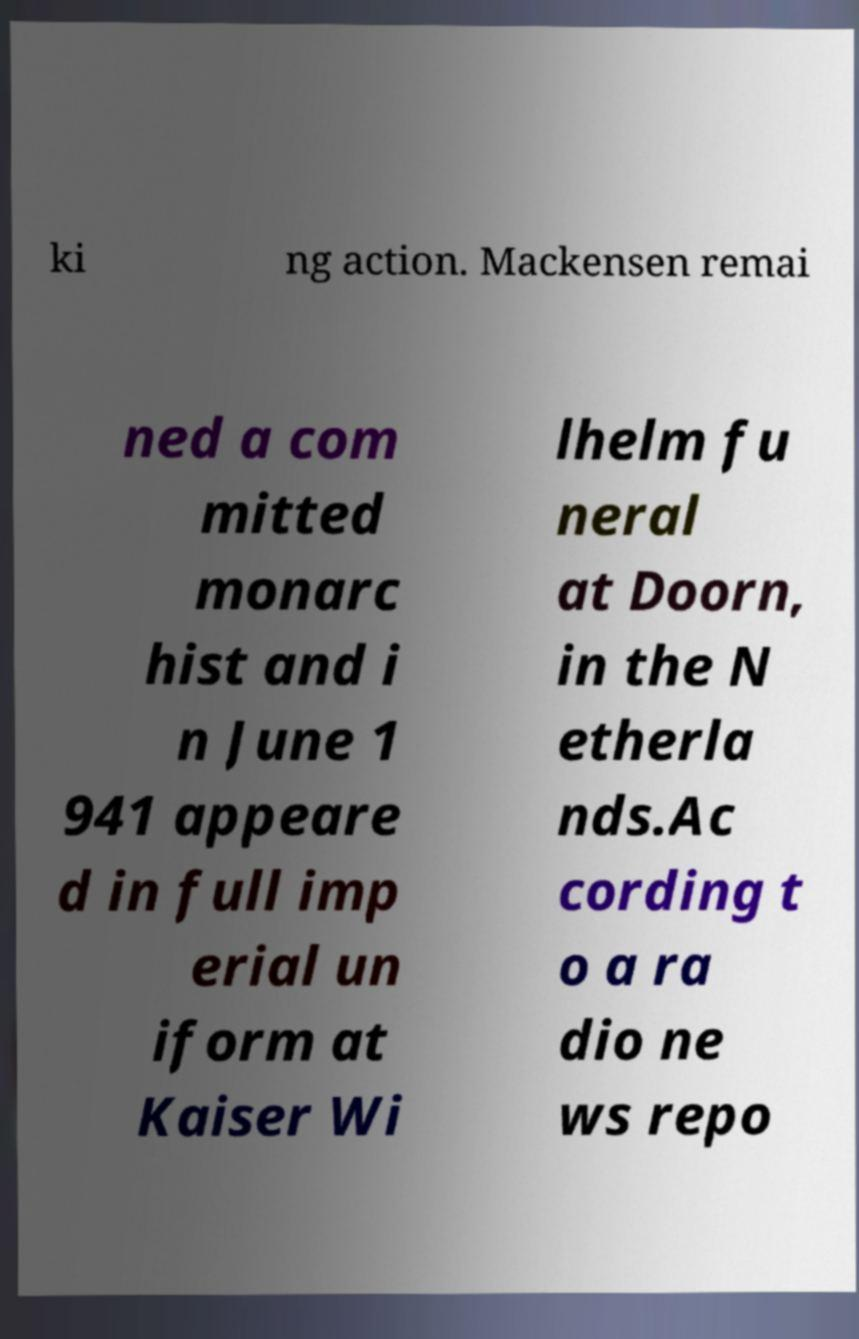Could you assist in decoding the text presented in this image and type it out clearly? ki ng action. Mackensen remai ned a com mitted monarc hist and i n June 1 941 appeare d in full imp erial un iform at Kaiser Wi lhelm fu neral at Doorn, in the N etherla nds.Ac cording t o a ra dio ne ws repo 